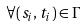Convert formula to latex. <formula><loc_0><loc_0><loc_500><loc_500>\forall ( s _ { i } , t _ { i } ) \in \Gamma</formula> 